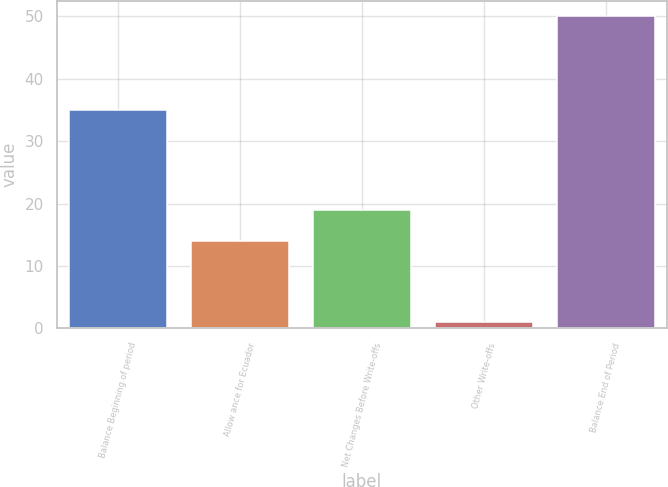Convert chart. <chart><loc_0><loc_0><loc_500><loc_500><bar_chart><fcel>Balance Beginning of period<fcel>Allow ance for Ecuador<fcel>Net Changes Before Write-offs<fcel>Other Write-offs<fcel>Balance End of Period<nl><fcel>35<fcel>14<fcel>18.9<fcel>1<fcel>50<nl></chart> 